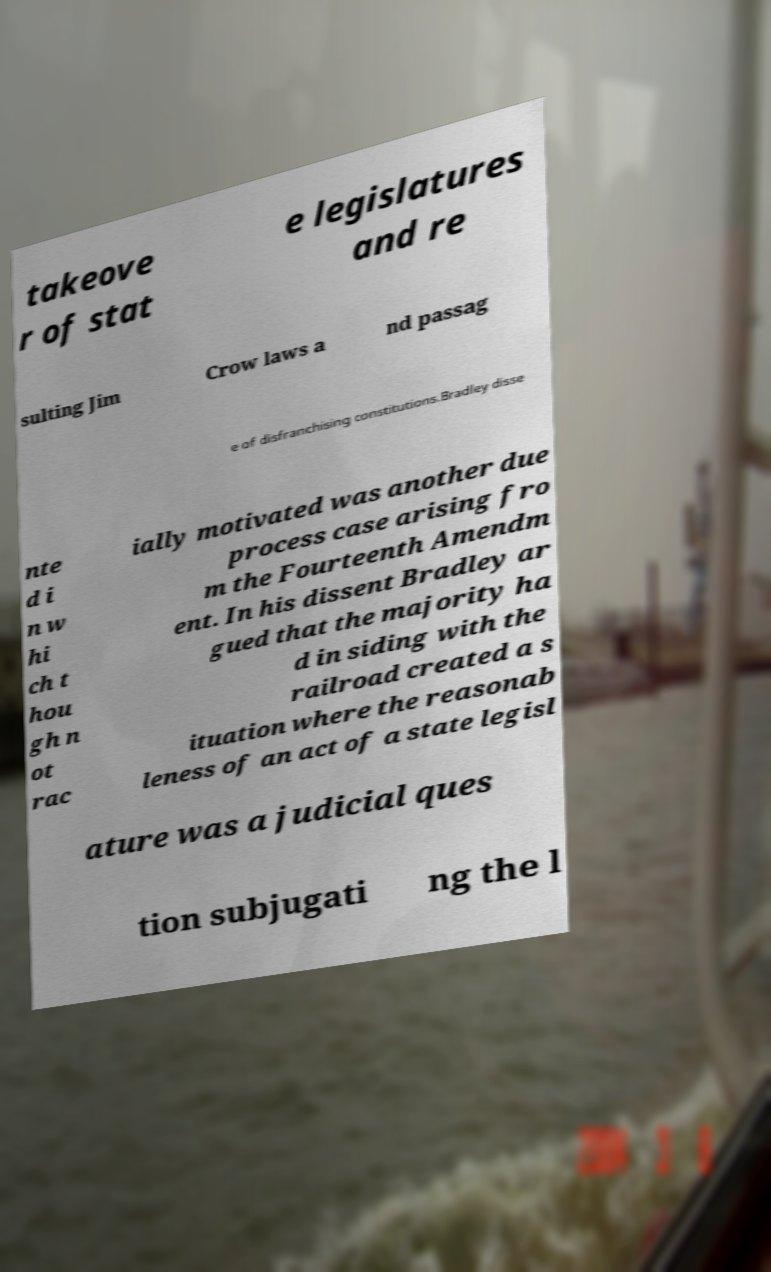Can you read and provide the text displayed in the image?This photo seems to have some interesting text. Can you extract and type it out for me? takeove r of stat e legislatures and re sulting Jim Crow laws a nd passag e of disfranchising constitutions.Bradley disse nte d i n w hi ch t hou gh n ot rac ially motivated was another due process case arising fro m the Fourteenth Amendm ent. In his dissent Bradley ar gued that the majority ha d in siding with the railroad created a s ituation where the reasonab leness of an act of a state legisl ature was a judicial ques tion subjugati ng the l 